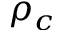Convert formula to latex. <formula><loc_0><loc_0><loc_500><loc_500>\rho _ { c }</formula> 